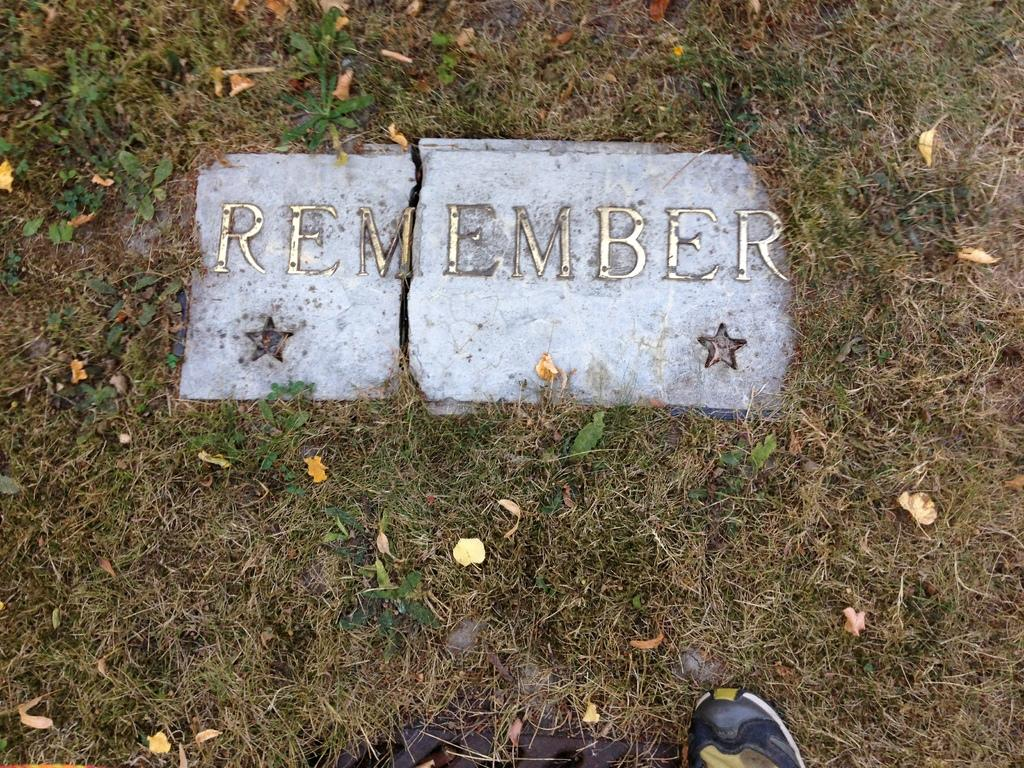What is the condition of the stone in the image? The stone in the image is broken. What message is written on the stone? The word "REMEMBER" is written on the stone. How many stars can be seen in the image? There are 2 stars visible in the image. What type of vegetation is present in the image? There is grass and leaves in the image. What is the object near the stone? There is a shoe in the image. What type of feather can be seen attached to the stone in the image? There is no feather present in the image; it only features a broken stone with the word "REMEMBER" written on it, stars, grass, leaves, and a shoe. 